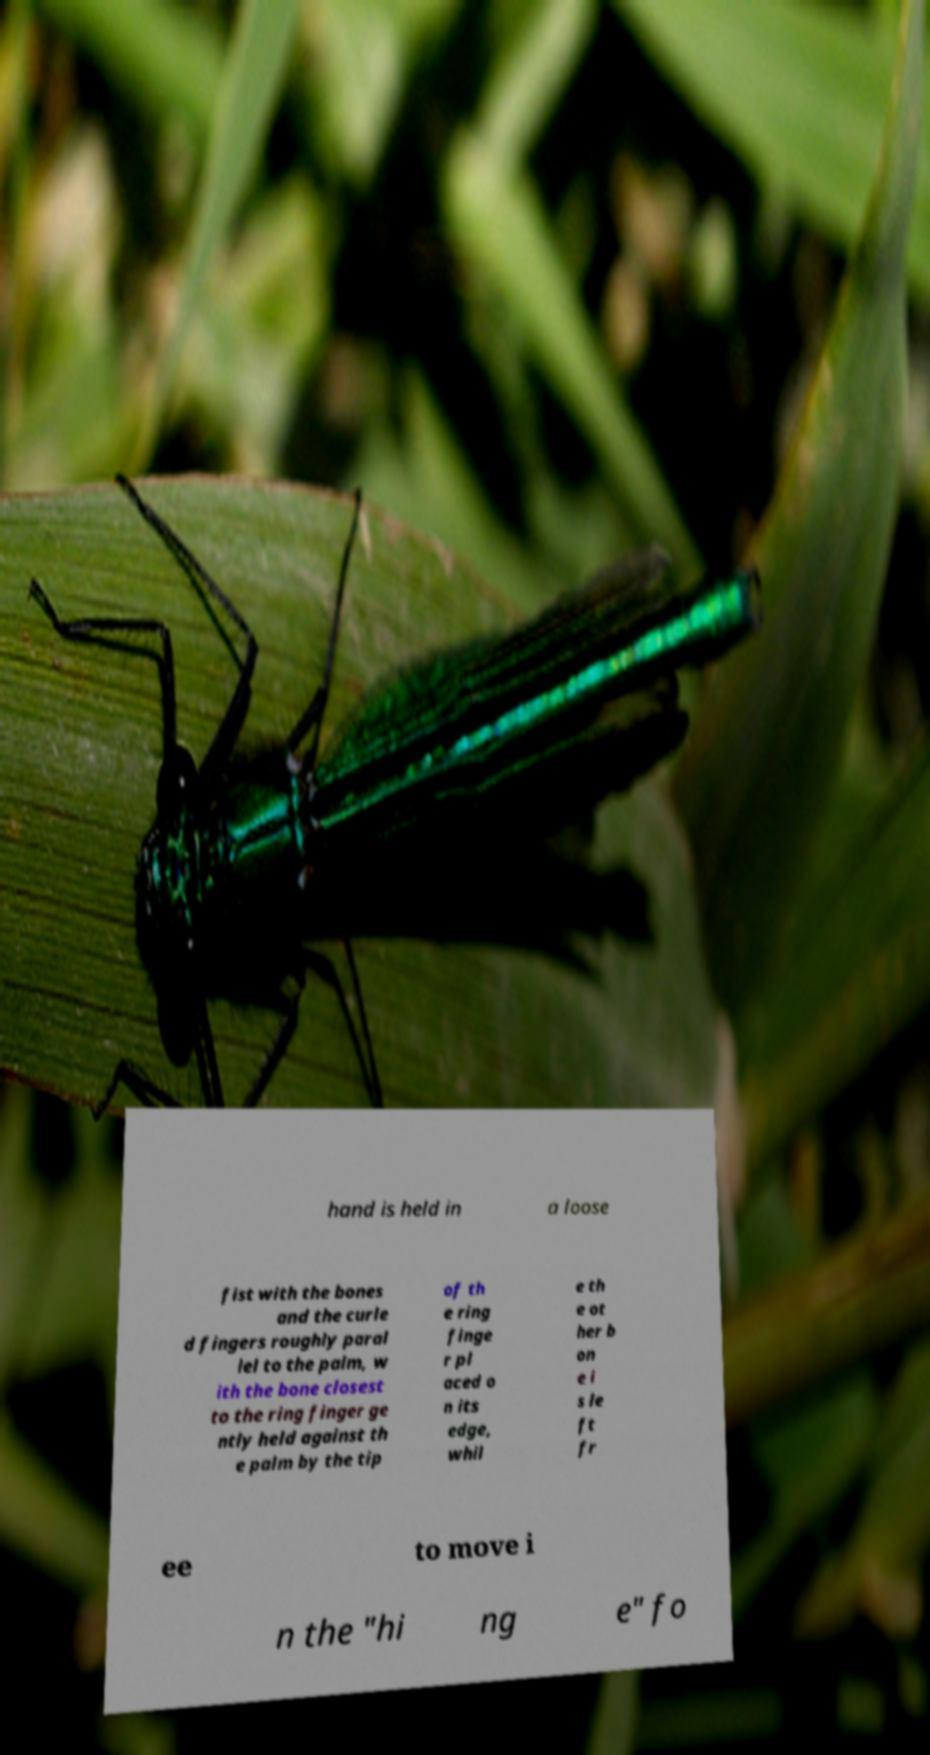There's text embedded in this image that I need extracted. Can you transcribe it verbatim? hand is held in a loose fist with the bones and the curle d fingers roughly paral lel to the palm, w ith the bone closest to the ring finger ge ntly held against th e palm by the tip of th e ring finge r pl aced o n its edge, whil e th e ot her b on e i s le ft fr ee to move i n the "hi ng e" fo 